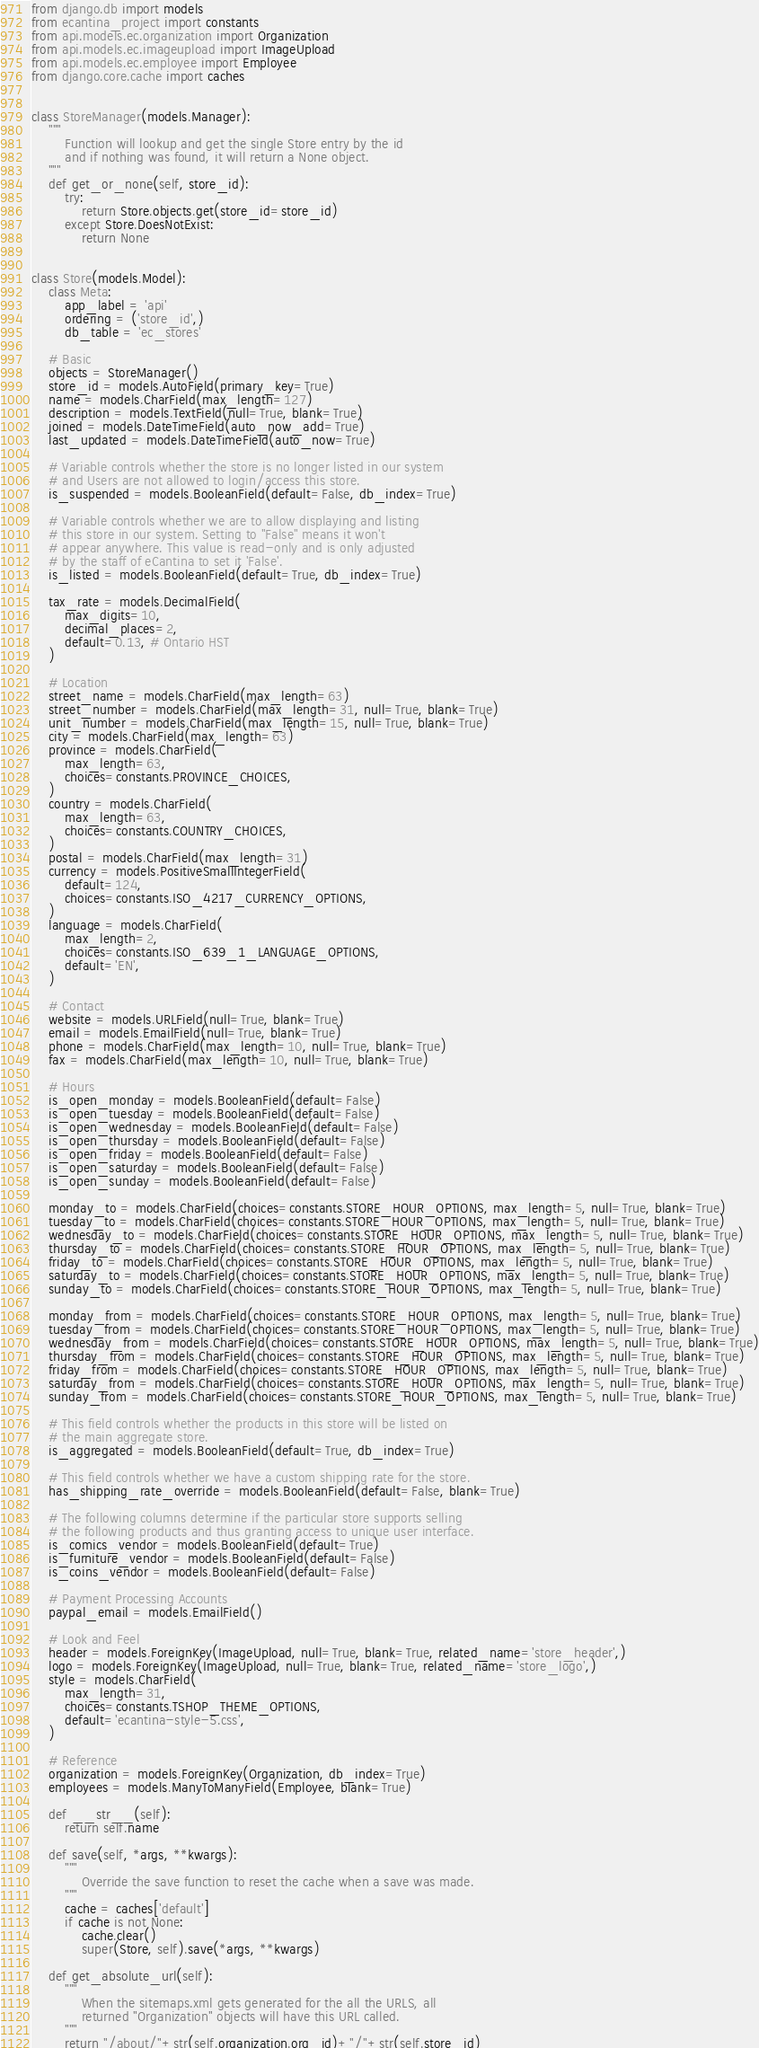<code> <loc_0><loc_0><loc_500><loc_500><_Python_>from django.db import models
from ecantina_project import constants
from api.models.ec.organization import Organization
from api.models.ec.imageupload import ImageUpload
from api.models.ec.employee import Employee
from django.core.cache import caches


class StoreManager(models.Manager):
    """
        Function will lookup and get the single Store entry by the id
        and if nothing was found, it will return a None object.
    """
    def get_or_none(self, store_id):
        try:
            return Store.objects.get(store_id=store_id)
        except Store.DoesNotExist:
            return None


class Store(models.Model):
    class Meta:
        app_label = 'api'
        ordering = ('store_id',)
        db_table = 'ec_stores'
    
    # Basic
    objects = StoreManager()
    store_id = models.AutoField(primary_key=True)
    name = models.CharField(max_length=127)
    description = models.TextField(null=True, blank=True)
    joined = models.DateTimeField(auto_now_add=True)
    last_updated = models.DateTimeField(auto_now=True)
    
    # Variable controls whether the store is no longer listed in our system
    # and Users are not allowed to login/access this store.
    is_suspended = models.BooleanField(default=False, db_index=True)
    
    # Variable controls whether we are to allow displaying and listing
    # this store in our system. Setting to "False" means it won't
    # appear anywhere. This value is read-only and is only adjusted
    # by the staff of eCantina to set it 'False'.
    is_listed = models.BooleanField(default=True, db_index=True)
    
    tax_rate = models.DecimalField(
        max_digits=10,
        decimal_places=2,
        default=0.13, # Ontario HST
    )
    
    # Location
    street_name = models.CharField(max_length=63)
    street_number = models.CharField(max_length=31, null=True, blank=True)
    unit_number = models.CharField(max_length=15, null=True, blank=True)
    city = models.CharField(max_length=63)
    province = models.CharField(
        max_length=63,
        choices=constants.PROVINCE_CHOICES,
    )
    country = models.CharField(
        max_length=63,
        choices=constants.COUNTRY_CHOICES,
    )
    postal = models.CharField(max_length=31)
    currency = models.PositiveSmallIntegerField(
        default=124,
        choices=constants.ISO_4217_CURRENCY_OPTIONS,
    )
    language = models.CharField(
        max_length=2,
        choices=constants.ISO_639_1_LANGUAGE_OPTIONS,
        default='EN',
    )
    
    # Contact
    website = models.URLField(null=True, blank=True)
    email = models.EmailField(null=True, blank=True)
    phone = models.CharField(max_length=10, null=True, blank=True)
    fax = models.CharField(max_length=10, null=True, blank=True)
    
    # Hours
    is_open_monday = models.BooleanField(default=False)
    is_open_tuesday = models.BooleanField(default=False)
    is_open_wednesday = models.BooleanField(default=False)
    is_open_thursday = models.BooleanField(default=False)
    is_open_friday = models.BooleanField(default=False)
    is_open_saturday = models.BooleanField(default=False)
    is_open_sunday = models.BooleanField(default=False)
    
    monday_to = models.CharField(choices=constants.STORE_HOUR_OPTIONS, max_length=5, null=True, blank=True)
    tuesday_to = models.CharField(choices=constants.STORE_HOUR_OPTIONS, max_length=5, null=True, blank=True)
    wednesday_to = models.CharField(choices=constants.STORE_HOUR_OPTIONS, max_length=5, null=True, blank=True)
    thursday_to = models.CharField(choices=constants.STORE_HOUR_OPTIONS, max_length=5, null=True, blank=True)
    friday_to = models.CharField(choices=constants.STORE_HOUR_OPTIONS, max_length=5, null=True, blank=True)
    saturday_to = models.CharField(choices=constants.STORE_HOUR_OPTIONS, max_length=5, null=True, blank=True)
    sunday_to = models.CharField(choices=constants.STORE_HOUR_OPTIONS, max_length=5, null=True, blank=True)
    
    monday_from = models.CharField(choices=constants.STORE_HOUR_OPTIONS, max_length=5, null=True, blank=True)
    tuesday_from = models.CharField(choices=constants.STORE_HOUR_OPTIONS, max_length=5, null=True, blank=True)
    wednesday_from = models.CharField(choices=constants.STORE_HOUR_OPTIONS, max_length=5, null=True, blank=True)
    thursday_from = models.CharField(choices=constants.STORE_HOUR_OPTIONS, max_length=5, null=True, blank=True)
    friday_from = models.CharField(choices=constants.STORE_HOUR_OPTIONS, max_length=5, null=True, blank=True)
    saturday_from = models.CharField(choices=constants.STORE_HOUR_OPTIONS, max_length=5, null=True, blank=True)
    sunday_from = models.CharField(choices=constants.STORE_HOUR_OPTIONS, max_length=5, null=True, blank=True)

    # This field controls whether the products in this store will be listed on
    # the main aggregate store.
    is_aggregated = models.BooleanField(default=True, db_index=True)

    # This field controls whether we have a custom shipping rate for the store.
    has_shipping_rate_override = models.BooleanField(default=False, blank=True)

    # The following columns determine if the particular store supports selling
    # the following products and thus granting access to unique user interface.
    is_comics_vendor = models.BooleanField(default=True)
    is_furniture_vendor = models.BooleanField(default=False)
    is_coins_vendor = models.BooleanField(default=False)
    
    # Payment Processing Accounts
    paypal_email = models.EmailField()
    
    # Look and Feel
    header = models.ForeignKey(ImageUpload, null=True, blank=True, related_name='store_header',)
    logo = models.ForeignKey(ImageUpload, null=True, blank=True, related_name='store_logo',)
    style = models.CharField(
        max_length=31,
        choices=constants.TSHOP_THEME_OPTIONS,
        default='ecantina-style-5.css',
    )
    
    # Reference
    organization = models.ForeignKey(Organization, db_index=True)
    employees = models.ManyToManyField(Employee, blank=True)
   
    def __str__(self):
        return self.name

    def save(self, *args, **kwargs):
        """
            Override the save function to reset the cache when a save was made.
        """
        cache = caches['default']
        if cache is not None:
            cache.clear()
            super(Store, self).save(*args, **kwargs)

    def get_absolute_url(self):
        """
            When the sitemaps.xml gets generated for the all the URLS, all
            returned "Organization" objects will have this URL called.
        """
        return "/about/"+str(self.organization.org_id)+"/"+str(self.store_id)
</code> 